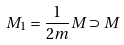Convert formula to latex. <formula><loc_0><loc_0><loc_500><loc_500>M _ { 1 } = \frac { 1 } { 2 m } M \supset M</formula> 